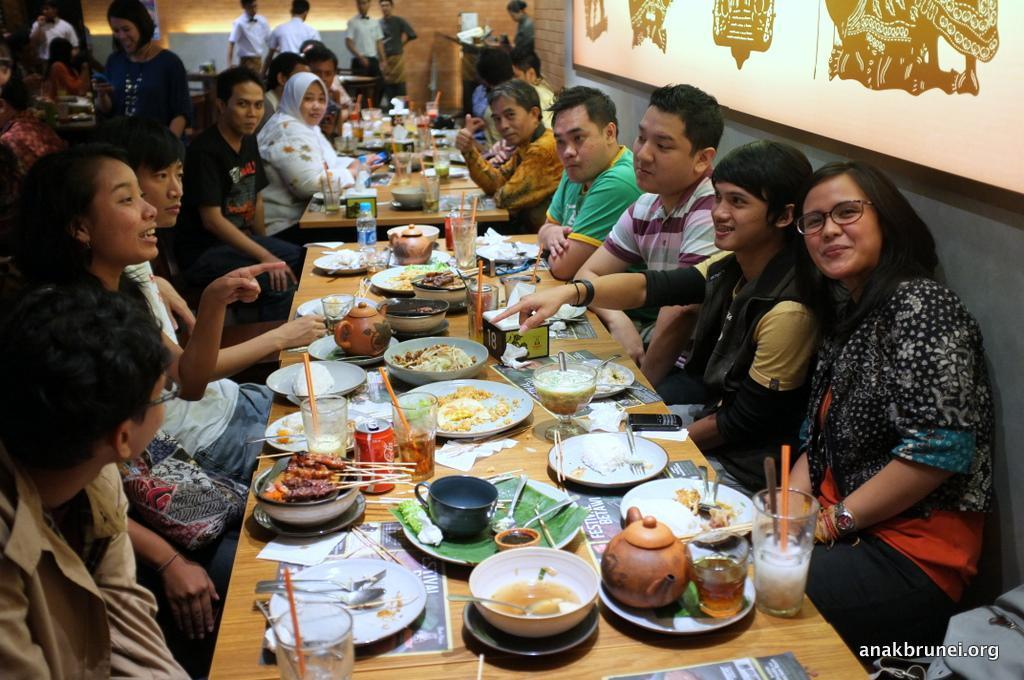Please provide a concise description of this image. In this picture there are a group of people sitting on the left and right they have a table in front of them, with lots of food served on it, there are plates, kettles, glasses, fork spoons and beverage cans on the table, there are some tissues, there is a mobile phone, there is a menu card and in the backdrop there are more people sitting and they also have a table in front of them in the background there are few people standing and onto the right there is a wall. 